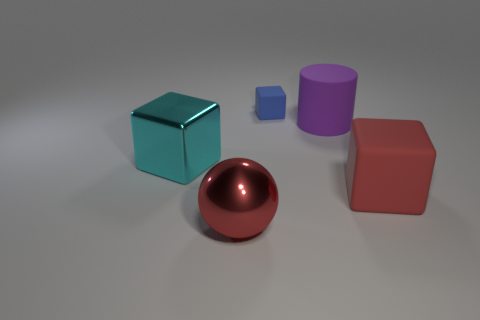Is there any other thing that is the same size as the blue cube?
Provide a short and direct response. No. Are there fewer large cyan shiny objects than large red objects?
Your answer should be very brief. Yes. Is the material of the cylinder the same as the tiny blue thing?
Ensure brevity in your answer.  Yes. How many other things are the same size as the red matte object?
Your answer should be compact. 3. What color is the matte block that is behind the metallic thing that is behind the large red shiny ball?
Your answer should be compact. Blue. How many other objects are the same shape as the cyan shiny object?
Your answer should be compact. 2. Is there a large ball that has the same material as the small blue cube?
Provide a short and direct response. No. What material is the red sphere that is the same size as the purple object?
Provide a short and direct response. Metal. There is a rubber block behind the large block that is right of the big metal thing that is behind the red sphere; what color is it?
Offer a very short reply. Blue. Do the rubber object that is in front of the cyan shiny block and the big metallic thing behind the red rubber thing have the same shape?
Your answer should be compact. Yes. 